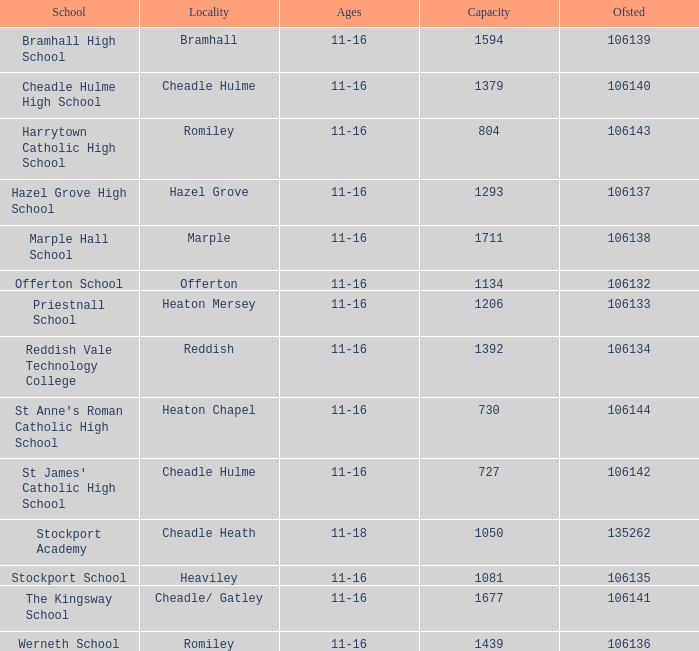What is heaton chapel's capacity? 730.0. 